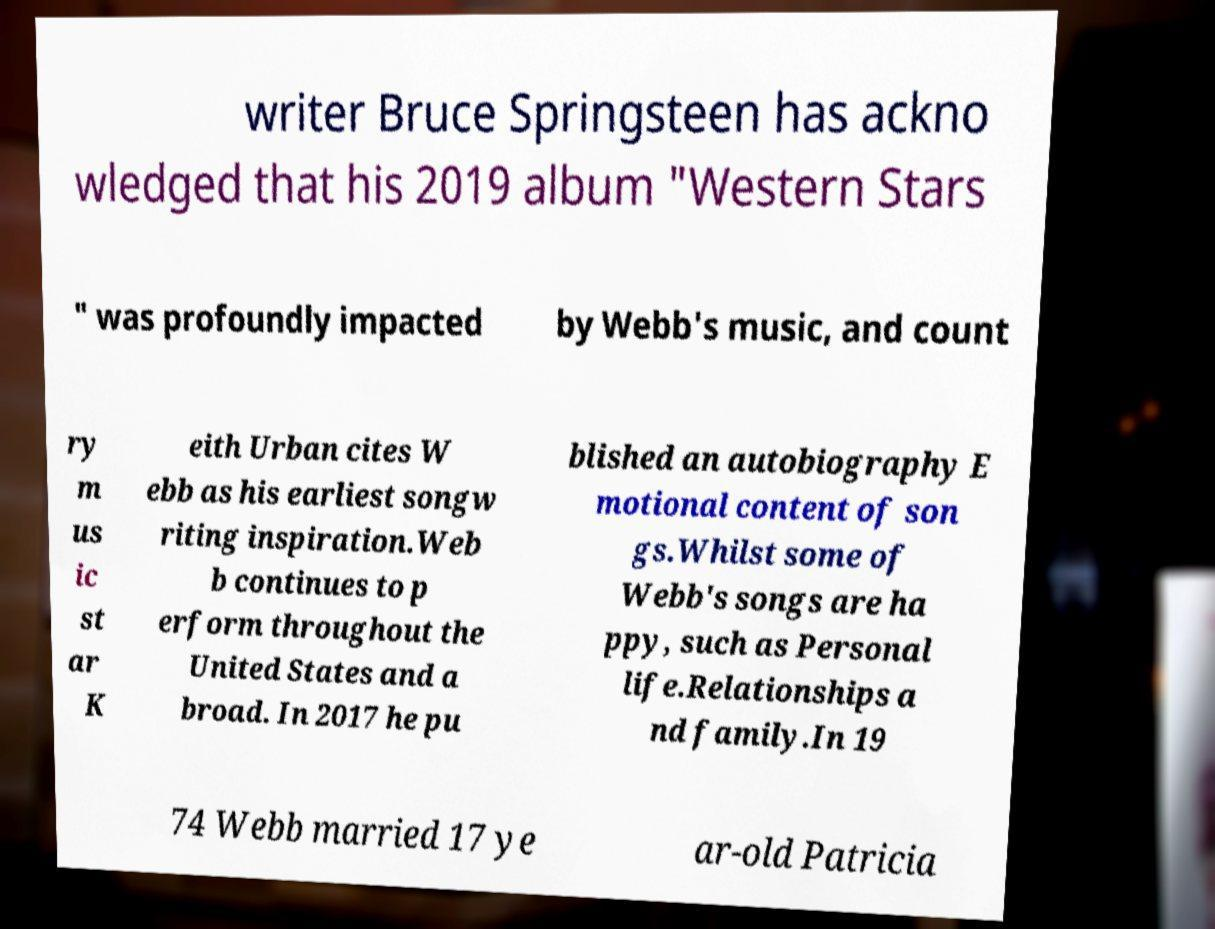What messages or text are displayed in this image? I need them in a readable, typed format. writer Bruce Springsteen has ackno wledged that his 2019 album "Western Stars " was profoundly impacted by Webb's music, and count ry m us ic st ar K eith Urban cites W ebb as his earliest songw riting inspiration.Web b continues to p erform throughout the United States and a broad. In 2017 he pu blished an autobiography E motional content of son gs.Whilst some of Webb's songs are ha ppy, such as Personal life.Relationships a nd family.In 19 74 Webb married 17 ye ar-old Patricia 